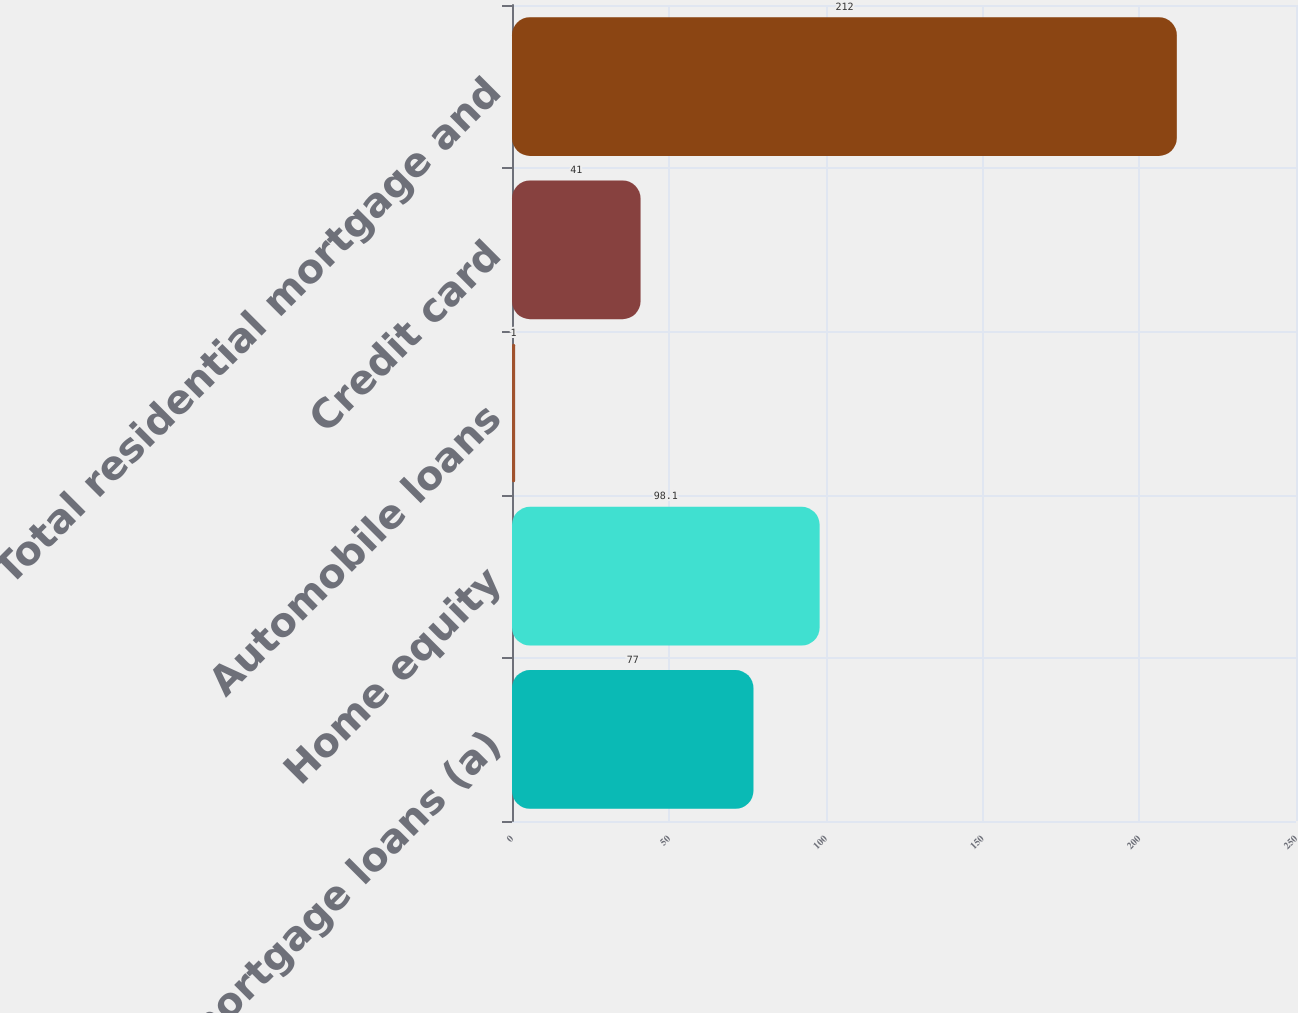Convert chart to OTSL. <chart><loc_0><loc_0><loc_500><loc_500><bar_chart><fcel>Residential mortgage loans (a)<fcel>Home equity<fcel>Automobile loans<fcel>Credit card<fcel>Total residential mortgage and<nl><fcel>77<fcel>98.1<fcel>1<fcel>41<fcel>212<nl></chart> 